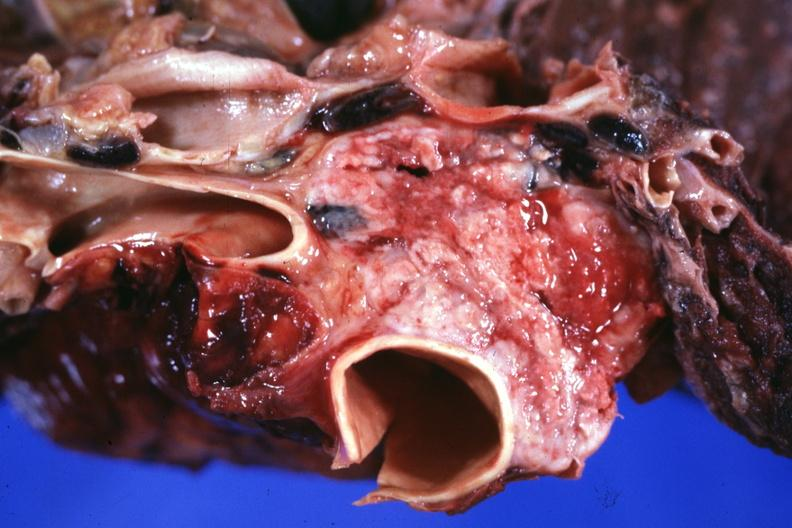s thymus present?
Answer the question using a single word or phrase. Yes 